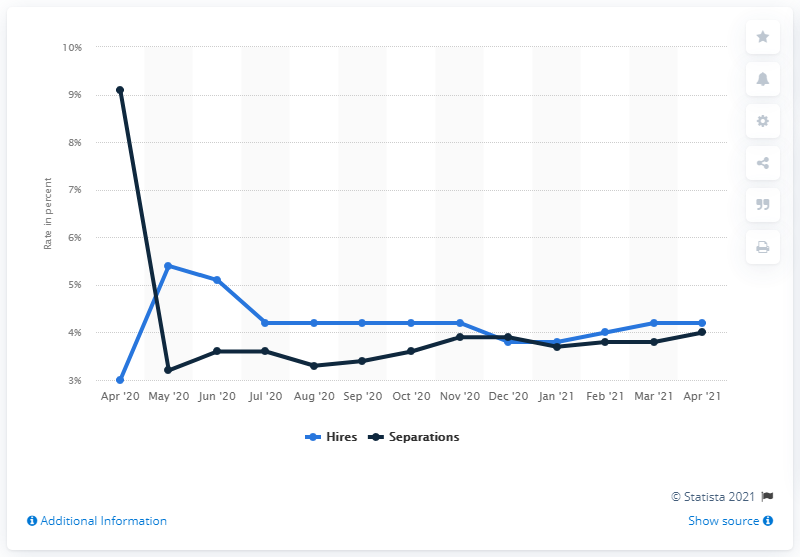Draw attention to some important aspects in this diagram. In April 2021, the hiring rate in the US was 4.2%. 